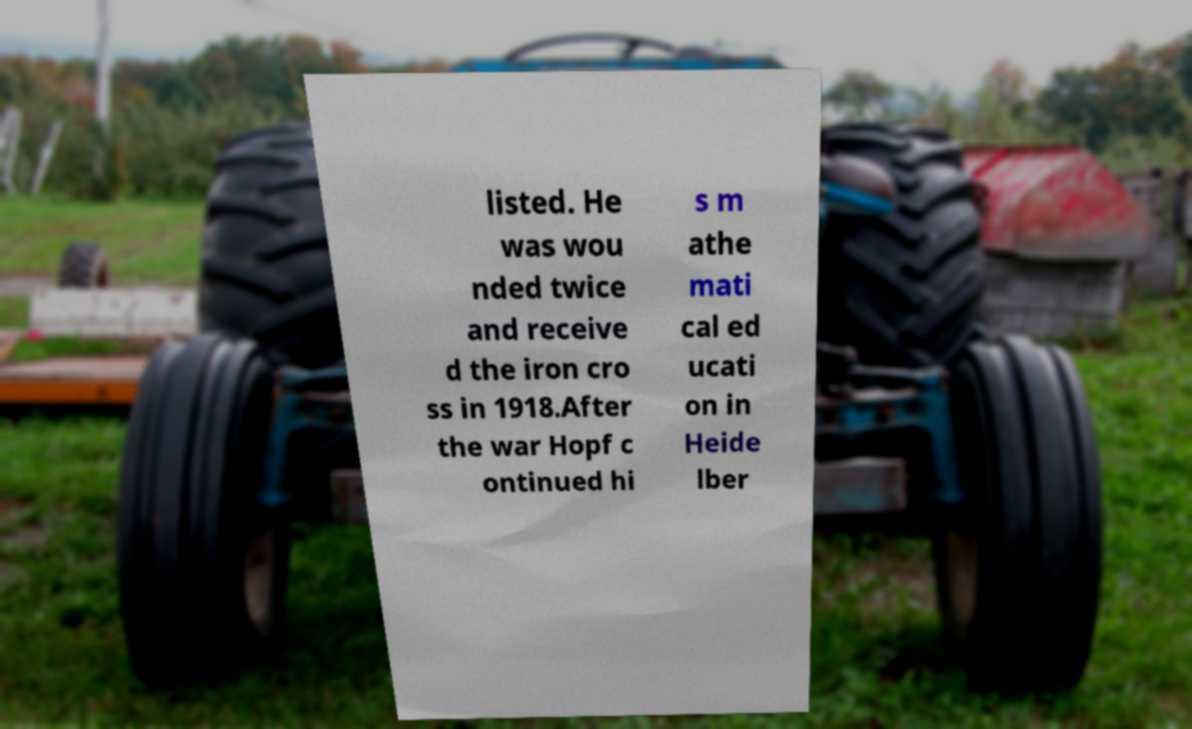I need the written content from this picture converted into text. Can you do that? listed. He was wou nded twice and receive d the iron cro ss in 1918.After the war Hopf c ontinued hi s m athe mati cal ed ucati on in Heide lber 